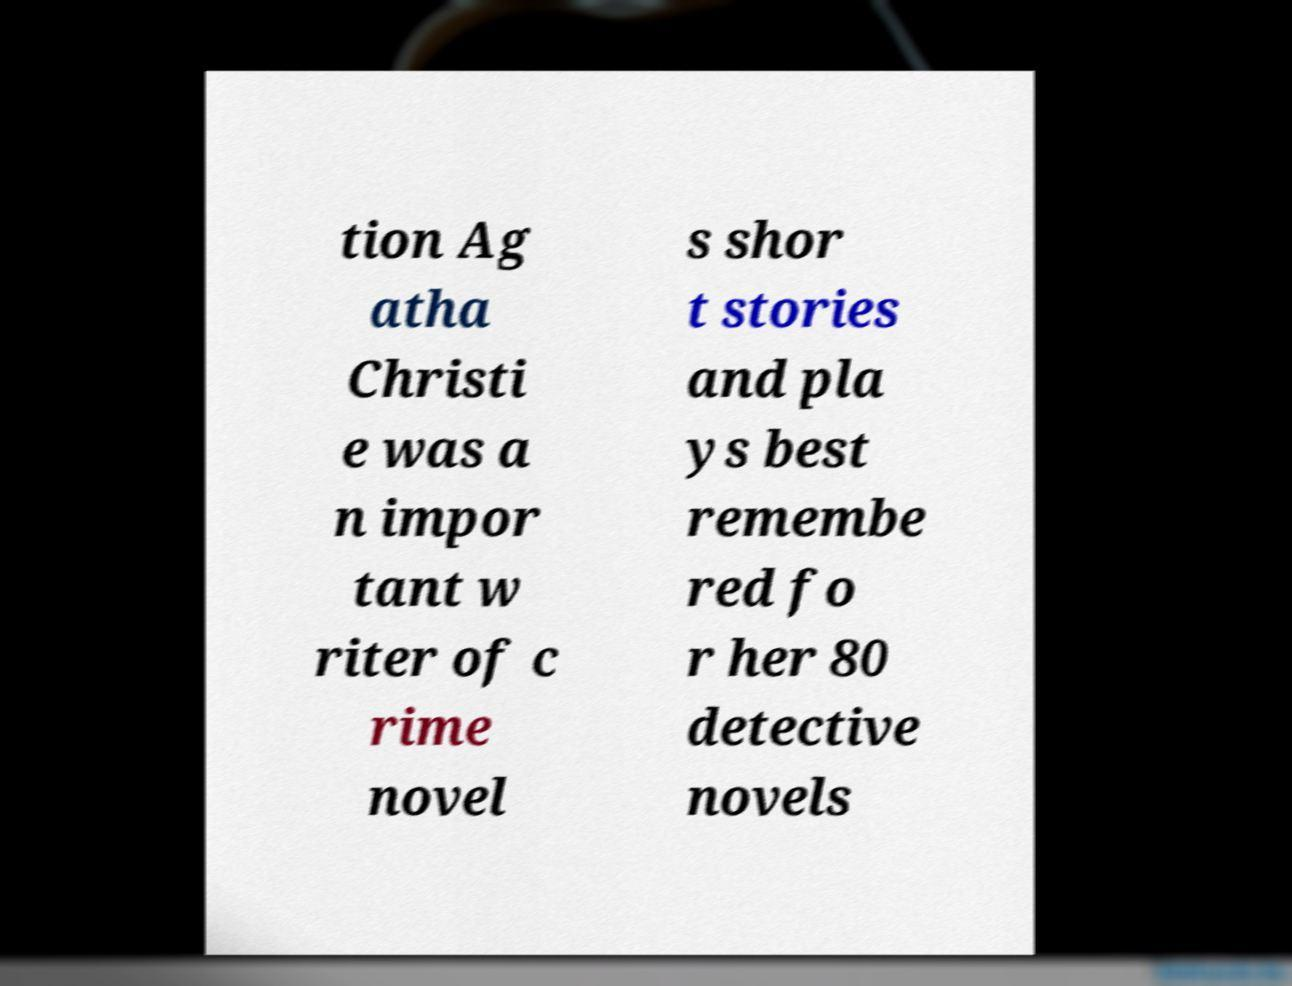Can you read and provide the text displayed in the image?This photo seems to have some interesting text. Can you extract and type it out for me? tion Ag atha Christi e was a n impor tant w riter of c rime novel s shor t stories and pla ys best remembe red fo r her 80 detective novels 